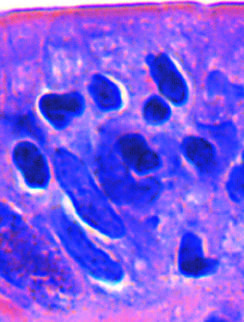can infiltration of the surface epithelium by t lymphocytes be recognized by their densely stained nuclei?
Answer the question using a single word or phrase. Yes 